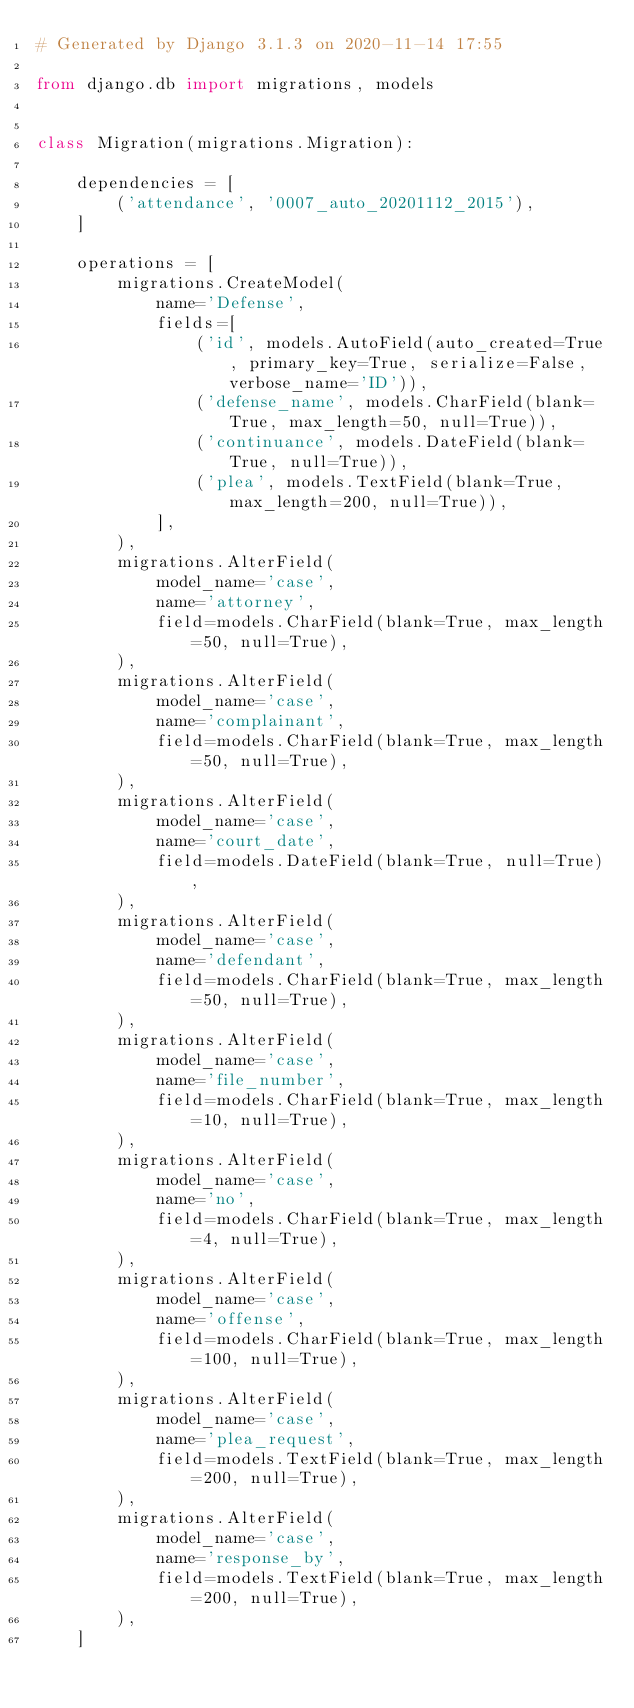<code> <loc_0><loc_0><loc_500><loc_500><_Python_># Generated by Django 3.1.3 on 2020-11-14 17:55

from django.db import migrations, models


class Migration(migrations.Migration):

    dependencies = [
        ('attendance', '0007_auto_20201112_2015'),
    ]

    operations = [
        migrations.CreateModel(
            name='Defense',
            fields=[
                ('id', models.AutoField(auto_created=True, primary_key=True, serialize=False, verbose_name='ID')),
                ('defense_name', models.CharField(blank=True, max_length=50, null=True)),
                ('continuance', models.DateField(blank=True, null=True)),
                ('plea', models.TextField(blank=True, max_length=200, null=True)),
            ],
        ),
        migrations.AlterField(
            model_name='case',
            name='attorney',
            field=models.CharField(blank=True, max_length=50, null=True),
        ),
        migrations.AlterField(
            model_name='case',
            name='complainant',
            field=models.CharField(blank=True, max_length=50, null=True),
        ),
        migrations.AlterField(
            model_name='case',
            name='court_date',
            field=models.DateField(blank=True, null=True),
        ),
        migrations.AlterField(
            model_name='case',
            name='defendant',
            field=models.CharField(blank=True, max_length=50, null=True),
        ),
        migrations.AlterField(
            model_name='case',
            name='file_number',
            field=models.CharField(blank=True, max_length=10, null=True),
        ),
        migrations.AlterField(
            model_name='case',
            name='no',
            field=models.CharField(blank=True, max_length=4, null=True),
        ),
        migrations.AlterField(
            model_name='case',
            name='offense',
            field=models.CharField(blank=True, max_length=100, null=True),
        ),
        migrations.AlterField(
            model_name='case',
            name='plea_request',
            field=models.TextField(blank=True, max_length=200, null=True),
        ),
        migrations.AlterField(
            model_name='case',
            name='response_by',
            field=models.TextField(blank=True, max_length=200, null=True),
        ),
    ]
</code> 